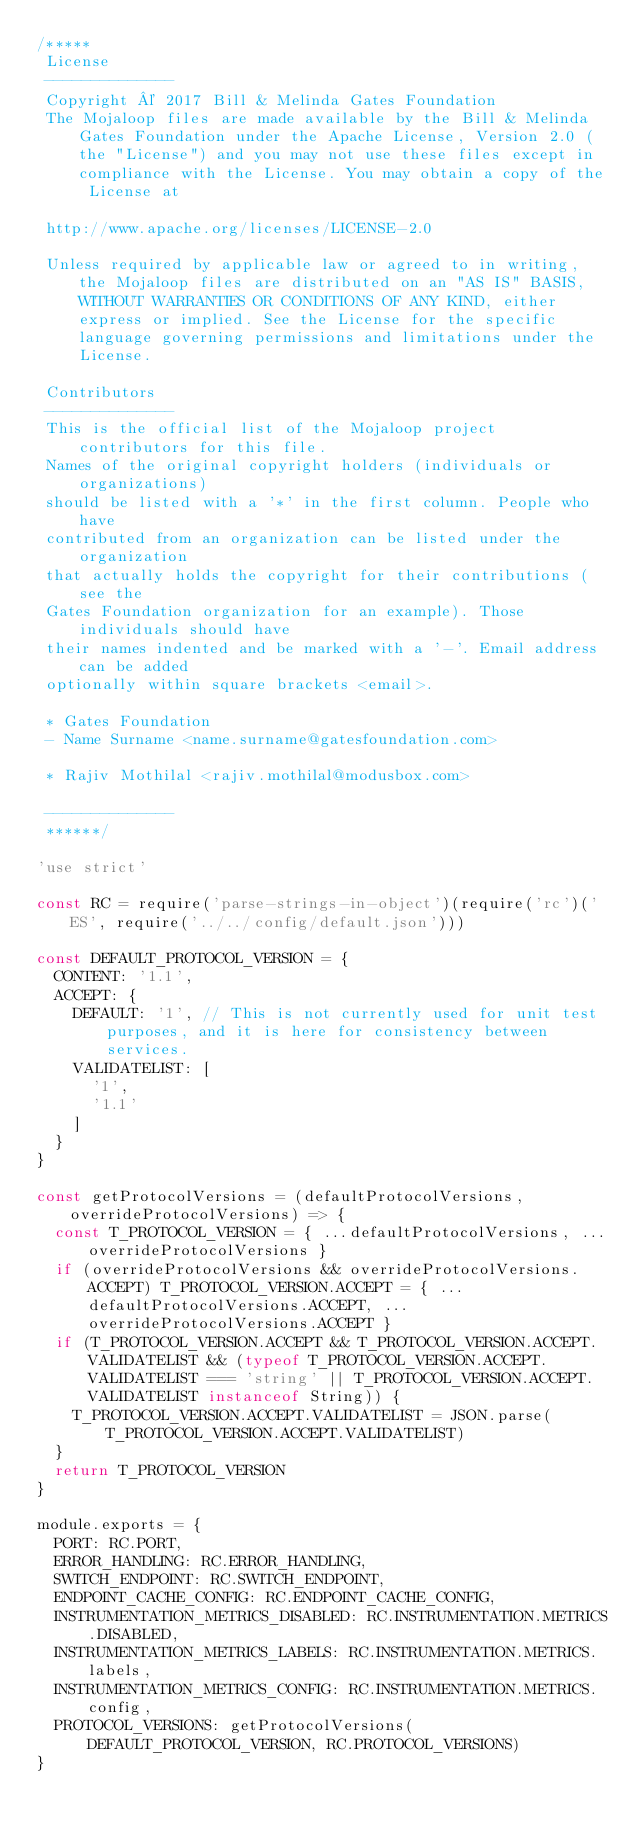<code> <loc_0><loc_0><loc_500><loc_500><_JavaScript_>/*****
 License
 --------------
 Copyright © 2017 Bill & Melinda Gates Foundation
 The Mojaloop files are made available by the Bill & Melinda Gates Foundation under the Apache License, Version 2.0 (the "License") and you may not use these files except in compliance with the License. You may obtain a copy of the License at

 http://www.apache.org/licenses/LICENSE-2.0

 Unless required by applicable law or agreed to in writing, the Mojaloop files are distributed on an "AS IS" BASIS, WITHOUT WARRANTIES OR CONDITIONS OF ANY KIND, either express or implied. See the License for the specific language governing permissions and limitations under the License.

 Contributors
 --------------
 This is the official list of the Mojaloop project contributors for this file.
 Names of the original copyright holders (individuals or organizations)
 should be listed with a '*' in the first column. People who have
 contributed from an organization can be listed under the organization
 that actually holds the copyright for their contributions (see the
 Gates Foundation organization for an example). Those individuals should have
 their names indented and be marked with a '-'. Email address can be added
 optionally within square brackets <email>.

 * Gates Foundation
 - Name Surname <name.surname@gatesfoundation.com>

 * Rajiv Mothilal <rajiv.mothilal@modusbox.com>

 --------------
 ******/

'use strict'

const RC = require('parse-strings-in-object')(require('rc')('ES', require('../../config/default.json')))

const DEFAULT_PROTOCOL_VERSION = {
  CONTENT: '1.1',
  ACCEPT: {
    DEFAULT: '1', // This is not currently used for unit test purposes, and it is here for consistency between services.
    VALIDATELIST: [
      '1',
      '1.1'
    ]
  }
}

const getProtocolVersions = (defaultProtocolVersions, overrideProtocolVersions) => {
  const T_PROTOCOL_VERSION = { ...defaultProtocolVersions, ...overrideProtocolVersions }
  if (overrideProtocolVersions && overrideProtocolVersions.ACCEPT) T_PROTOCOL_VERSION.ACCEPT = { ...defaultProtocolVersions.ACCEPT, ...overrideProtocolVersions.ACCEPT }
  if (T_PROTOCOL_VERSION.ACCEPT && T_PROTOCOL_VERSION.ACCEPT.VALIDATELIST && (typeof T_PROTOCOL_VERSION.ACCEPT.VALIDATELIST === 'string' || T_PROTOCOL_VERSION.ACCEPT.VALIDATELIST instanceof String)) {
    T_PROTOCOL_VERSION.ACCEPT.VALIDATELIST = JSON.parse(T_PROTOCOL_VERSION.ACCEPT.VALIDATELIST)
  }
  return T_PROTOCOL_VERSION
}

module.exports = {
  PORT: RC.PORT,
  ERROR_HANDLING: RC.ERROR_HANDLING,
  SWITCH_ENDPOINT: RC.SWITCH_ENDPOINT,
  ENDPOINT_CACHE_CONFIG: RC.ENDPOINT_CACHE_CONFIG,
  INSTRUMENTATION_METRICS_DISABLED: RC.INSTRUMENTATION.METRICS.DISABLED,
  INSTRUMENTATION_METRICS_LABELS: RC.INSTRUMENTATION.METRICS.labels,
  INSTRUMENTATION_METRICS_CONFIG: RC.INSTRUMENTATION.METRICS.config,
  PROTOCOL_VERSIONS: getProtocolVersions(DEFAULT_PROTOCOL_VERSION, RC.PROTOCOL_VERSIONS)
}
</code> 